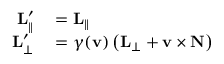Convert formula to latex. <formula><loc_0><loc_0><loc_500><loc_500>\begin{array} { r l } { L _ { \| } ^ { \prime } } & = L _ { \| } } \\ { L _ { \perp } ^ { \prime } } & = \gamma ( v ) \left ( L _ { \perp } + v \times N \right ) } \end{array}</formula> 